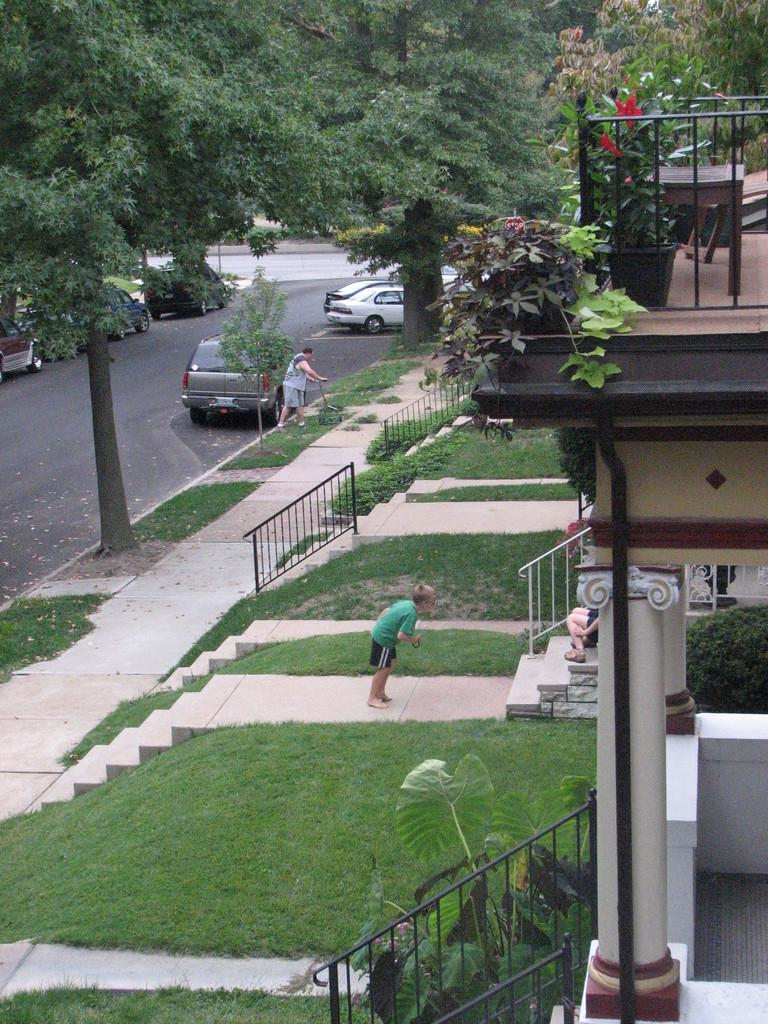What can be seen on the road in the image? There are vehicles on the road in the image. Who or what else is present in the image? There is a group of people in the image. What type of structure is visible in the image? There is a house in the image. What type of vegetation can be seen in the image? There are plants, grass, and trees in the image. What architectural feature is present in the image? There are iron grills and stairs in the image. How many children are playing during recess in the image? There is no mention of children or recess in the image; it features vehicles on the road, a group of people, a house, plants, iron grills, grass, stairs, and trees. What type of cats can be seen climbing the trees in the image? There are no cats present in the image; it features vehicles on the road, a group of people, a house, plants, iron grills, grass, stairs, and trees. 